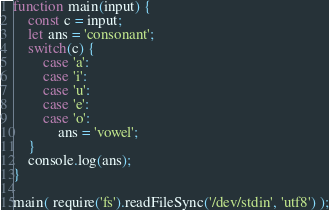<code> <loc_0><loc_0><loc_500><loc_500><_TypeScript_>function main(input) {
    const c = input;
    let ans = 'consonant';
    switch(c) {
        case 'a':
        case 'i':
        case 'u':
        case 'e':
        case 'o':
            ans = 'vowel';
    }
    console.log(ans);
}

main( require('fs').readFileSync('/dev/stdin', 'utf8') );</code> 